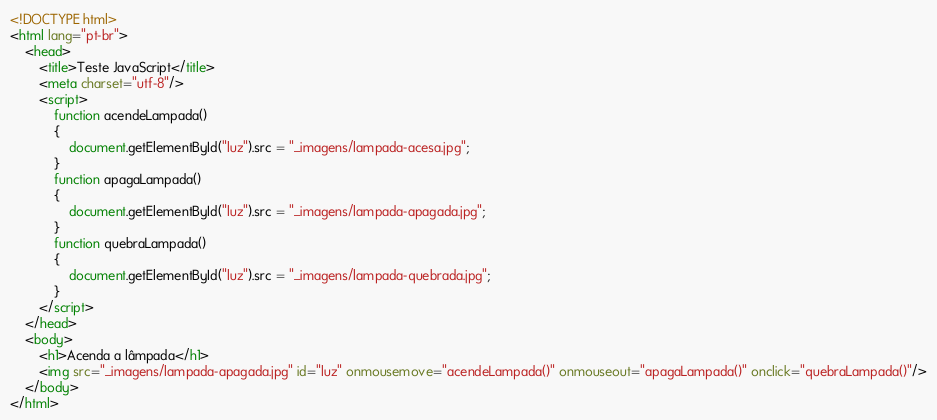Convert code to text. <code><loc_0><loc_0><loc_500><loc_500><_HTML_><!DOCTYPE html>
<html lang="pt-br">
    <head>
        <title>Teste JavaScript</title>
        <meta charset="utf-8"/>
        <script>
            function acendeLampada() 
            {
                document.getElementById("luz").src = "_imagens/lampada-acesa.jpg";
            }
            function apagaLampada()
            {
                document.getElementById("luz").src = "_imagens/lampada-apagada.jpg";
            }
            function quebraLampada()
            {
                document.getElementById("luz").src = "_imagens/lampada-quebrada.jpg";
            }
        </script>
    </head>
    <body>
        <h1>Acenda a lâmpada</h1>
        <img src="_imagens/lampada-apagada.jpg" id="luz" onmousemove="acendeLampada()" onmouseout="apagaLampada()" onclick="quebraLampada()"/>
    </body>
</html></code> 